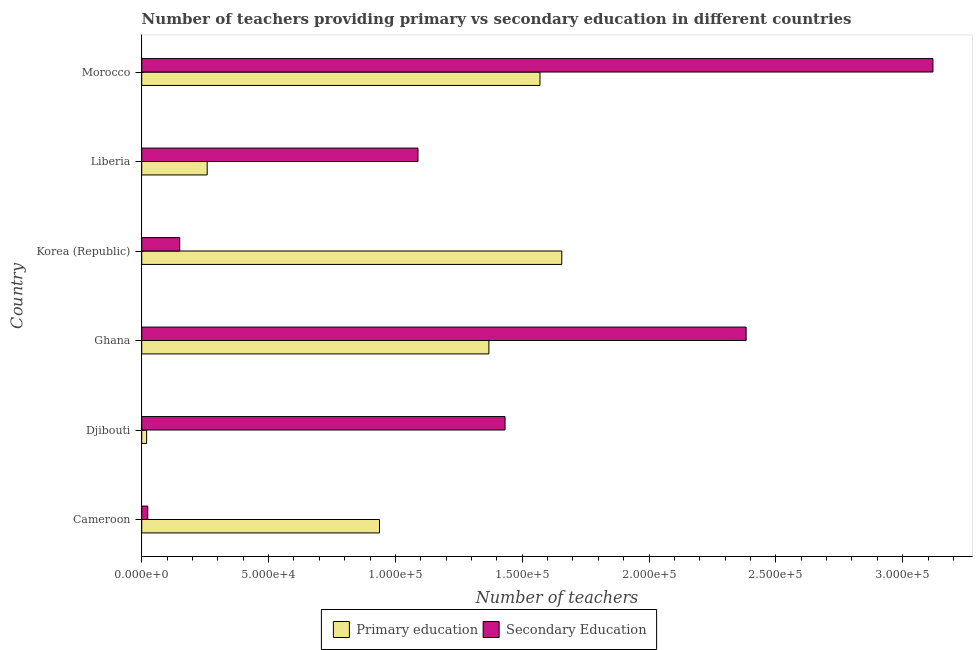How many different coloured bars are there?
Provide a succinct answer. 2. How many groups of bars are there?
Keep it short and to the point. 6. Are the number of bars per tick equal to the number of legend labels?
Provide a short and direct response. Yes. How many bars are there on the 6th tick from the top?
Make the answer very short. 2. What is the number of primary teachers in Korea (Republic)?
Provide a short and direct response. 1.66e+05. Across all countries, what is the maximum number of primary teachers?
Your answer should be very brief. 1.66e+05. Across all countries, what is the minimum number of secondary teachers?
Make the answer very short. 2386. In which country was the number of primary teachers maximum?
Your answer should be compact. Korea (Republic). In which country was the number of secondary teachers minimum?
Keep it short and to the point. Cameroon. What is the total number of primary teachers in the graph?
Make the answer very short. 5.81e+05. What is the difference between the number of secondary teachers in Cameroon and that in Liberia?
Offer a terse response. -1.07e+05. What is the difference between the number of primary teachers in Ghana and the number of secondary teachers in Korea (Republic)?
Provide a succinct answer. 1.22e+05. What is the average number of primary teachers per country?
Keep it short and to the point. 9.68e+04. What is the difference between the number of primary teachers and number of secondary teachers in Cameroon?
Make the answer very short. 9.14e+04. In how many countries, is the number of secondary teachers greater than 70000 ?
Ensure brevity in your answer.  4. What is the ratio of the number of secondary teachers in Djibouti to that in Morocco?
Provide a short and direct response. 0.46. Is the number of primary teachers in Cameroon less than that in Korea (Republic)?
Offer a terse response. Yes. Is the difference between the number of secondary teachers in Cameroon and Ghana greater than the difference between the number of primary teachers in Cameroon and Ghana?
Provide a short and direct response. No. What is the difference between the highest and the second highest number of primary teachers?
Your answer should be compact. 8596. What is the difference between the highest and the lowest number of secondary teachers?
Offer a very short reply. 3.10e+05. What does the 1st bar from the bottom in Liberia represents?
Give a very brief answer. Primary education. How many bars are there?
Provide a short and direct response. 12. How many countries are there in the graph?
Give a very brief answer. 6. Does the graph contain any zero values?
Offer a terse response. No. Where does the legend appear in the graph?
Ensure brevity in your answer.  Bottom center. How many legend labels are there?
Ensure brevity in your answer.  2. What is the title of the graph?
Your answer should be very brief. Number of teachers providing primary vs secondary education in different countries. Does "Merchandise imports" appear as one of the legend labels in the graph?
Keep it short and to the point. No. What is the label or title of the X-axis?
Your response must be concise. Number of teachers. What is the label or title of the Y-axis?
Offer a terse response. Country. What is the Number of teachers of Primary education in Cameroon?
Make the answer very short. 9.37e+04. What is the Number of teachers of Secondary Education in Cameroon?
Give a very brief answer. 2386. What is the Number of teachers in Primary education in Djibouti?
Make the answer very short. 1935. What is the Number of teachers of Secondary Education in Djibouti?
Provide a succinct answer. 1.43e+05. What is the Number of teachers in Primary education in Ghana?
Your response must be concise. 1.37e+05. What is the Number of teachers in Secondary Education in Ghana?
Ensure brevity in your answer.  2.38e+05. What is the Number of teachers of Primary education in Korea (Republic)?
Provide a succinct answer. 1.66e+05. What is the Number of teachers of Secondary Education in Korea (Republic)?
Give a very brief answer. 1.50e+04. What is the Number of teachers in Primary education in Liberia?
Make the answer very short. 2.58e+04. What is the Number of teachers of Secondary Education in Liberia?
Your answer should be very brief. 1.09e+05. What is the Number of teachers in Primary education in Morocco?
Keep it short and to the point. 1.57e+05. What is the Number of teachers of Secondary Education in Morocco?
Give a very brief answer. 3.12e+05. Across all countries, what is the maximum Number of teachers of Primary education?
Keep it short and to the point. 1.66e+05. Across all countries, what is the maximum Number of teachers in Secondary Education?
Give a very brief answer. 3.12e+05. Across all countries, what is the minimum Number of teachers of Primary education?
Offer a very short reply. 1935. Across all countries, what is the minimum Number of teachers in Secondary Education?
Your answer should be very brief. 2386. What is the total Number of teachers of Primary education in the graph?
Make the answer very short. 5.81e+05. What is the total Number of teachers in Secondary Education in the graph?
Offer a very short reply. 8.20e+05. What is the difference between the Number of teachers in Primary education in Cameroon and that in Djibouti?
Offer a very short reply. 9.18e+04. What is the difference between the Number of teachers in Secondary Education in Cameroon and that in Djibouti?
Provide a short and direct response. -1.41e+05. What is the difference between the Number of teachers of Primary education in Cameroon and that in Ghana?
Ensure brevity in your answer.  -4.31e+04. What is the difference between the Number of teachers of Secondary Education in Cameroon and that in Ghana?
Offer a very short reply. -2.36e+05. What is the difference between the Number of teachers of Primary education in Cameroon and that in Korea (Republic)?
Keep it short and to the point. -7.19e+04. What is the difference between the Number of teachers of Secondary Education in Cameroon and that in Korea (Republic)?
Ensure brevity in your answer.  -1.26e+04. What is the difference between the Number of teachers of Primary education in Cameroon and that in Liberia?
Make the answer very short. 6.79e+04. What is the difference between the Number of teachers in Secondary Education in Cameroon and that in Liberia?
Your response must be concise. -1.07e+05. What is the difference between the Number of teachers of Primary education in Cameroon and that in Morocco?
Offer a very short reply. -6.33e+04. What is the difference between the Number of teachers of Secondary Education in Cameroon and that in Morocco?
Provide a short and direct response. -3.10e+05. What is the difference between the Number of teachers of Primary education in Djibouti and that in Ghana?
Provide a short and direct response. -1.35e+05. What is the difference between the Number of teachers in Secondary Education in Djibouti and that in Ghana?
Provide a short and direct response. -9.50e+04. What is the difference between the Number of teachers of Primary education in Djibouti and that in Korea (Republic)?
Offer a very short reply. -1.64e+05. What is the difference between the Number of teachers of Secondary Education in Djibouti and that in Korea (Republic)?
Keep it short and to the point. 1.28e+05. What is the difference between the Number of teachers of Primary education in Djibouti and that in Liberia?
Provide a short and direct response. -2.39e+04. What is the difference between the Number of teachers of Secondary Education in Djibouti and that in Liberia?
Ensure brevity in your answer.  3.43e+04. What is the difference between the Number of teachers of Primary education in Djibouti and that in Morocco?
Offer a terse response. -1.55e+05. What is the difference between the Number of teachers of Secondary Education in Djibouti and that in Morocco?
Your answer should be compact. -1.69e+05. What is the difference between the Number of teachers of Primary education in Ghana and that in Korea (Republic)?
Provide a succinct answer. -2.87e+04. What is the difference between the Number of teachers of Secondary Education in Ghana and that in Korea (Republic)?
Your answer should be compact. 2.23e+05. What is the difference between the Number of teachers in Primary education in Ghana and that in Liberia?
Keep it short and to the point. 1.11e+05. What is the difference between the Number of teachers of Secondary Education in Ghana and that in Liberia?
Provide a succinct answer. 1.29e+05. What is the difference between the Number of teachers of Primary education in Ghana and that in Morocco?
Offer a terse response. -2.01e+04. What is the difference between the Number of teachers of Secondary Education in Ghana and that in Morocco?
Your response must be concise. -7.36e+04. What is the difference between the Number of teachers of Primary education in Korea (Republic) and that in Liberia?
Your answer should be compact. 1.40e+05. What is the difference between the Number of teachers in Secondary Education in Korea (Republic) and that in Liberia?
Provide a succinct answer. -9.39e+04. What is the difference between the Number of teachers of Primary education in Korea (Republic) and that in Morocco?
Your answer should be very brief. 8596. What is the difference between the Number of teachers of Secondary Education in Korea (Republic) and that in Morocco?
Offer a terse response. -2.97e+05. What is the difference between the Number of teachers of Primary education in Liberia and that in Morocco?
Make the answer very short. -1.31e+05. What is the difference between the Number of teachers in Secondary Education in Liberia and that in Morocco?
Ensure brevity in your answer.  -2.03e+05. What is the difference between the Number of teachers in Primary education in Cameroon and the Number of teachers in Secondary Education in Djibouti?
Provide a succinct answer. -4.95e+04. What is the difference between the Number of teachers in Primary education in Cameroon and the Number of teachers in Secondary Education in Ghana?
Keep it short and to the point. -1.45e+05. What is the difference between the Number of teachers of Primary education in Cameroon and the Number of teachers of Secondary Education in Korea (Republic)?
Ensure brevity in your answer.  7.88e+04. What is the difference between the Number of teachers in Primary education in Cameroon and the Number of teachers in Secondary Education in Liberia?
Provide a short and direct response. -1.52e+04. What is the difference between the Number of teachers in Primary education in Cameroon and the Number of teachers in Secondary Education in Morocco?
Provide a succinct answer. -2.18e+05. What is the difference between the Number of teachers of Primary education in Djibouti and the Number of teachers of Secondary Education in Ghana?
Your answer should be compact. -2.36e+05. What is the difference between the Number of teachers in Primary education in Djibouti and the Number of teachers in Secondary Education in Korea (Republic)?
Give a very brief answer. -1.30e+04. What is the difference between the Number of teachers in Primary education in Djibouti and the Number of teachers in Secondary Education in Liberia?
Provide a short and direct response. -1.07e+05. What is the difference between the Number of teachers of Primary education in Djibouti and the Number of teachers of Secondary Education in Morocco?
Your response must be concise. -3.10e+05. What is the difference between the Number of teachers of Primary education in Ghana and the Number of teachers of Secondary Education in Korea (Republic)?
Offer a terse response. 1.22e+05. What is the difference between the Number of teachers in Primary education in Ghana and the Number of teachers in Secondary Education in Liberia?
Give a very brief answer. 2.80e+04. What is the difference between the Number of teachers in Primary education in Ghana and the Number of teachers in Secondary Education in Morocco?
Ensure brevity in your answer.  -1.75e+05. What is the difference between the Number of teachers in Primary education in Korea (Republic) and the Number of teachers in Secondary Education in Liberia?
Your answer should be very brief. 5.67e+04. What is the difference between the Number of teachers of Primary education in Korea (Republic) and the Number of teachers of Secondary Education in Morocco?
Your answer should be compact. -1.46e+05. What is the difference between the Number of teachers in Primary education in Liberia and the Number of teachers in Secondary Education in Morocco?
Offer a terse response. -2.86e+05. What is the average Number of teachers of Primary education per country?
Ensure brevity in your answer.  9.68e+04. What is the average Number of teachers of Secondary Education per country?
Your answer should be compact. 1.37e+05. What is the difference between the Number of teachers of Primary education and Number of teachers of Secondary Education in Cameroon?
Your answer should be very brief. 9.14e+04. What is the difference between the Number of teachers in Primary education and Number of teachers in Secondary Education in Djibouti?
Provide a succinct answer. -1.41e+05. What is the difference between the Number of teachers of Primary education and Number of teachers of Secondary Education in Ghana?
Offer a terse response. -1.01e+05. What is the difference between the Number of teachers in Primary education and Number of teachers in Secondary Education in Korea (Republic)?
Make the answer very short. 1.51e+05. What is the difference between the Number of teachers of Primary education and Number of teachers of Secondary Education in Liberia?
Offer a terse response. -8.31e+04. What is the difference between the Number of teachers in Primary education and Number of teachers in Secondary Education in Morocco?
Provide a short and direct response. -1.55e+05. What is the ratio of the Number of teachers of Primary education in Cameroon to that in Djibouti?
Your answer should be very brief. 48.44. What is the ratio of the Number of teachers of Secondary Education in Cameroon to that in Djibouti?
Provide a short and direct response. 0.02. What is the ratio of the Number of teachers of Primary education in Cameroon to that in Ghana?
Provide a succinct answer. 0.68. What is the ratio of the Number of teachers of Secondary Education in Cameroon to that in Ghana?
Your answer should be very brief. 0.01. What is the ratio of the Number of teachers in Primary education in Cameroon to that in Korea (Republic)?
Make the answer very short. 0.57. What is the ratio of the Number of teachers of Secondary Education in Cameroon to that in Korea (Republic)?
Your answer should be compact. 0.16. What is the ratio of the Number of teachers in Primary education in Cameroon to that in Liberia?
Provide a short and direct response. 3.63. What is the ratio of the Number of teachers of Secondary Education in Cameroon to that in Liberia?
Your answer should be very brief. 0.02. What is the ratio of the Number of teachers of Primary education in Cameroon to that in Morocco?
Your response must be concise. 0.6. What is the ratio of the Number of teachers of Secondary Education in Cameroon to that in Morocco?
Provide a short and direct response. 0.01. What is the ratio of the Number of teachers of Primary education in Djibouti to that in Ghana?
Provide a succinct answer. 0.01. What is the ratio of the Number of teachers in Secondary Education in Djibouti to that in Ghana?
Your answer should be compact. 0.6. What is the ratio of the Number of teachers in Primary education in Djibouti to that in Korea (Republic)?
Keep it short and to the point. 0.01. What is the ratio of the Number of teachers in Secondary Education in Djibouti to that in Korea (Republic)?
Provide a short and direct response. 9.57. What is the ratio of the Number of teachers in Primary education in Djibouti to that in Liberia?
Ensure brevity in your answer.  0.07. What is the ratio of the Number of teachers of Secondary Education in Djibouti to that in Liberia?
Offer a very short reply. 1.32. What is the ratio of the Number of teachers of Primary education in Djibouti to that in Morocco?
Keep it short and to the point. 0.01. What is the ratio of the Number of teachers in Secondary Education in Djibouti to that in Morocco?
Your answer should be very brief. 0.46. What is the ratio of the Number of teachers of Primary education in Ghana to that in Korea (Republic)?
Your answer should be compact. 0.83. What is the ratio of the Number of teachers of Secondary Education in Ghana to that in Korea (Republic)?
Give a very brief answer. 15.91. What is the ratio of the Number of teachers of Primary education in Ghana to that in Liberia?
Offer a terse response. 5.3. What is the ratio of the Number of teachers in Secondary Education in Ghana to that in Liberia?
Offer a terse response. 2.19. What is the ratio of the Number of teachers in Primary education in Ghana to that in Morocco?
Offer a terse response. 0.87. What is the ratio of the Number of teachers of Secondary Education in Ghana to that in Morocco?
Keep it short and to the point. 0.76. What is the ratio of the Number of teachers of Primary education in Korea (Republic) to that in Liberia?
Offer a very short reply. 6.42. What is the ratio of the Number of teachers in Secondary Education in Korea (Republic) to that in Liberia?
Keep it short and to the point. 0.14. What is the ratio of the Number of teachers in Primary education in Korea (Republic) to that in Morocco?
Ensure brevity in your answer.  1.05. What is the ratio of the Number of teachers in Secondary Education in Korea (Republic) to that in Morocco?
Your response must be concise. 0.05. What is the ratio of the Number of teachers in Primary education in Liberia to that in Morocco?
Offer a very short reply. 0.16. What is the ratio of the Number of teachers of Secondary Education in Liberia to that in Morocco?
Make the answer very short. 0.35. What is the difference between the highest and the second highest Number of teachers of Primary education?
Provide a short and direct response. 8596. What is the difference between the highest and the second highest Number of teachers in Secondary Education?
Ensure brevity in your answer.  7.36e+04. What is the difference between the highest and the lowest Number of teachers of Primary education?
Offer a very short reply. 1.64e+05. What is the difference between the highest and the lowest Number of teachers in Secondary Education?
Make the answer very short. 3.10e+05. 